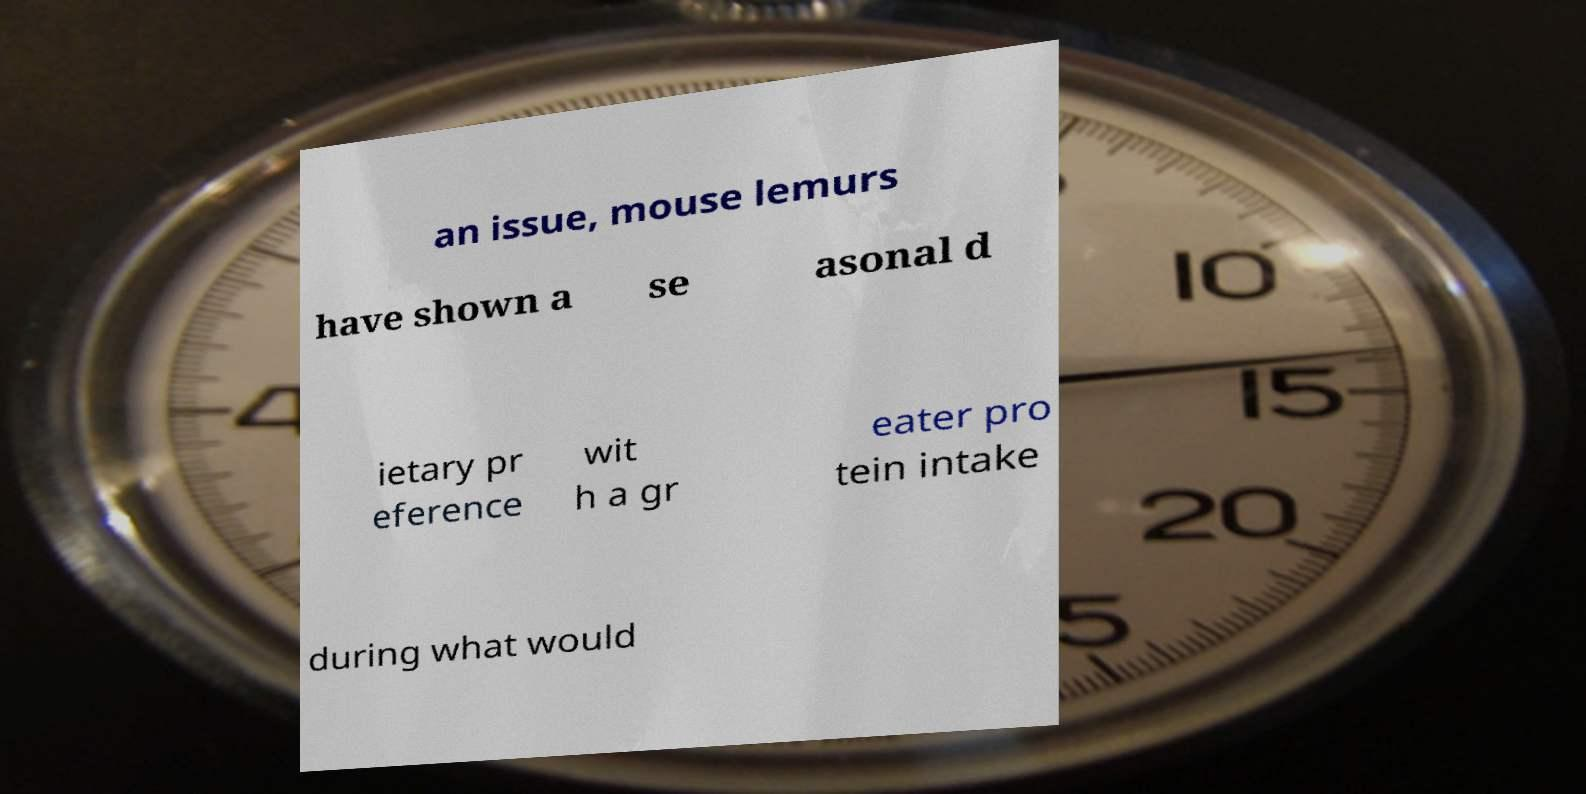What messages or text are displayed in this image? I need them in a readable, typed format. an issue, mouse lemurs have shown a se asonal d ietary pr eference wit h a gr eater pro tein intake during what would 